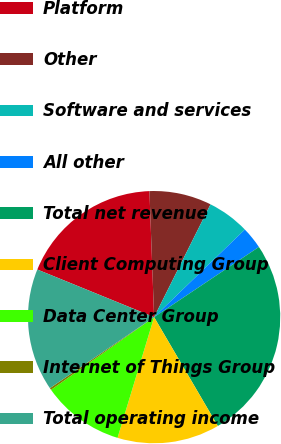Convert chart. <chart><loc_0><loc_0><loc_500><loc_500><pie_chart><fcel>Platform<fcel>Other<fcel>Software and services<fcel>All other<fcel>Total net revenue<fcel>Client Computing Group<fcel>Data Center Group<fcel>Internet of Things Group<fcel>Total operating income<nl><fcel>18.25%<fcel>7.97%<fcel>5.4%<fcel>2.83%<fcel>25.96%<fcel>13.11%<fcel>10.54%<fcel>0.26%<fcel>15.68%<nl></chart> 